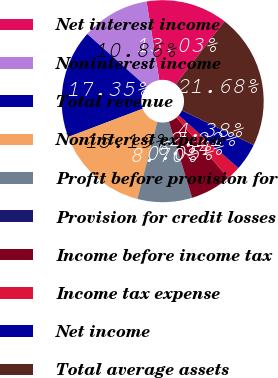Convert chart. <chart><loc_0><loc_0><loc_500><loc_500><pie_chart><fcel>Net interest income<fcel>Noninterest income<fcel>Total revenue<fcel>Noninterest expense<fcel>Profit before provision for<fcel>Provision for credit losses<fcel>Income before income tax<fcel>Income tax expense<fcel>Net income<fcel>Total average assets<nl><fcel>13.03%<fcel>10.86%<fcel>17.35%<fcel>15.19%<fcel>8.7%<fcel>0.05%<fcel>6.54%<fcel>2.22%<fcel>4.38%<fcel>21.68%<nl></chart> 